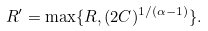<formula> <loc_0><loc_0><loc_500><loc_500>R ^ { \prime } = \max \{ R , ( 2 C ) ^ { 1 / ( \alpha - 1 ) } \} .</formula> 